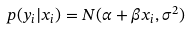Convert formula to latex. <formula><loc_0><loc_0><loc_500><loc_500>p ( y _ { i } | x _ { i } ) = N ( \alpha + \beta x _ { i } , \sigma ^ { 2 } )</formula> 